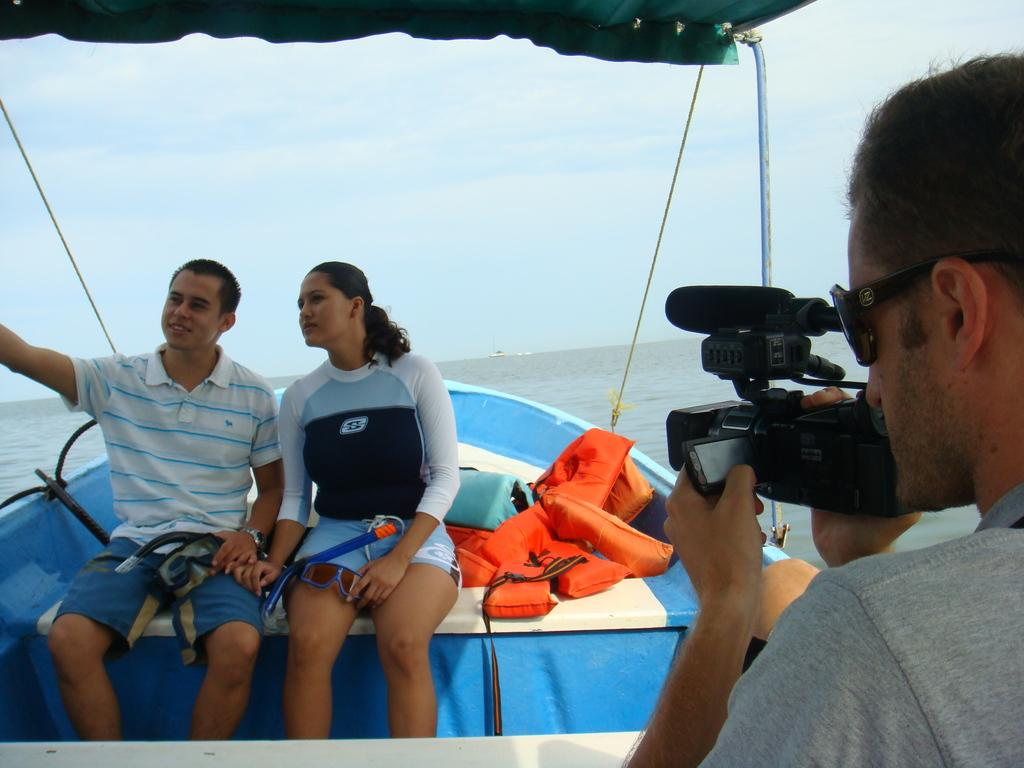How many people are on the boat in the image? There are two people sitting on the boat in the image. What are the lifeguards doing in the image? The lifeguards are beside the people on the boat. What is the guy on the opposite side of the boat doing? The guy is shooting (taking a picture of) the people on the boat. Where was the image taken? The image was clicked on a boat. Is there a stove visible on the boat in the image? No, there is no stove present in the image. Can you describe the island in the background of the image? There is no island visible in the image; it is focused on the people on the boat and the guy taking a picture. 